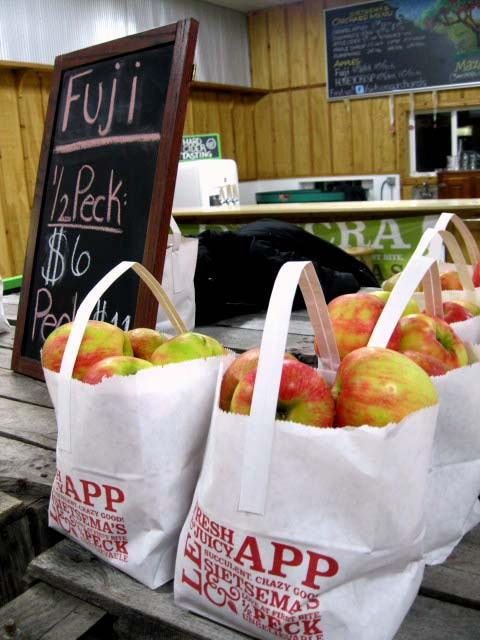Is this image taken indoors or outdoors? The image appears to have been taken indoors, as evidenced by the wooden panels on the walls suggesting an interior space common in markets or farm stands. 